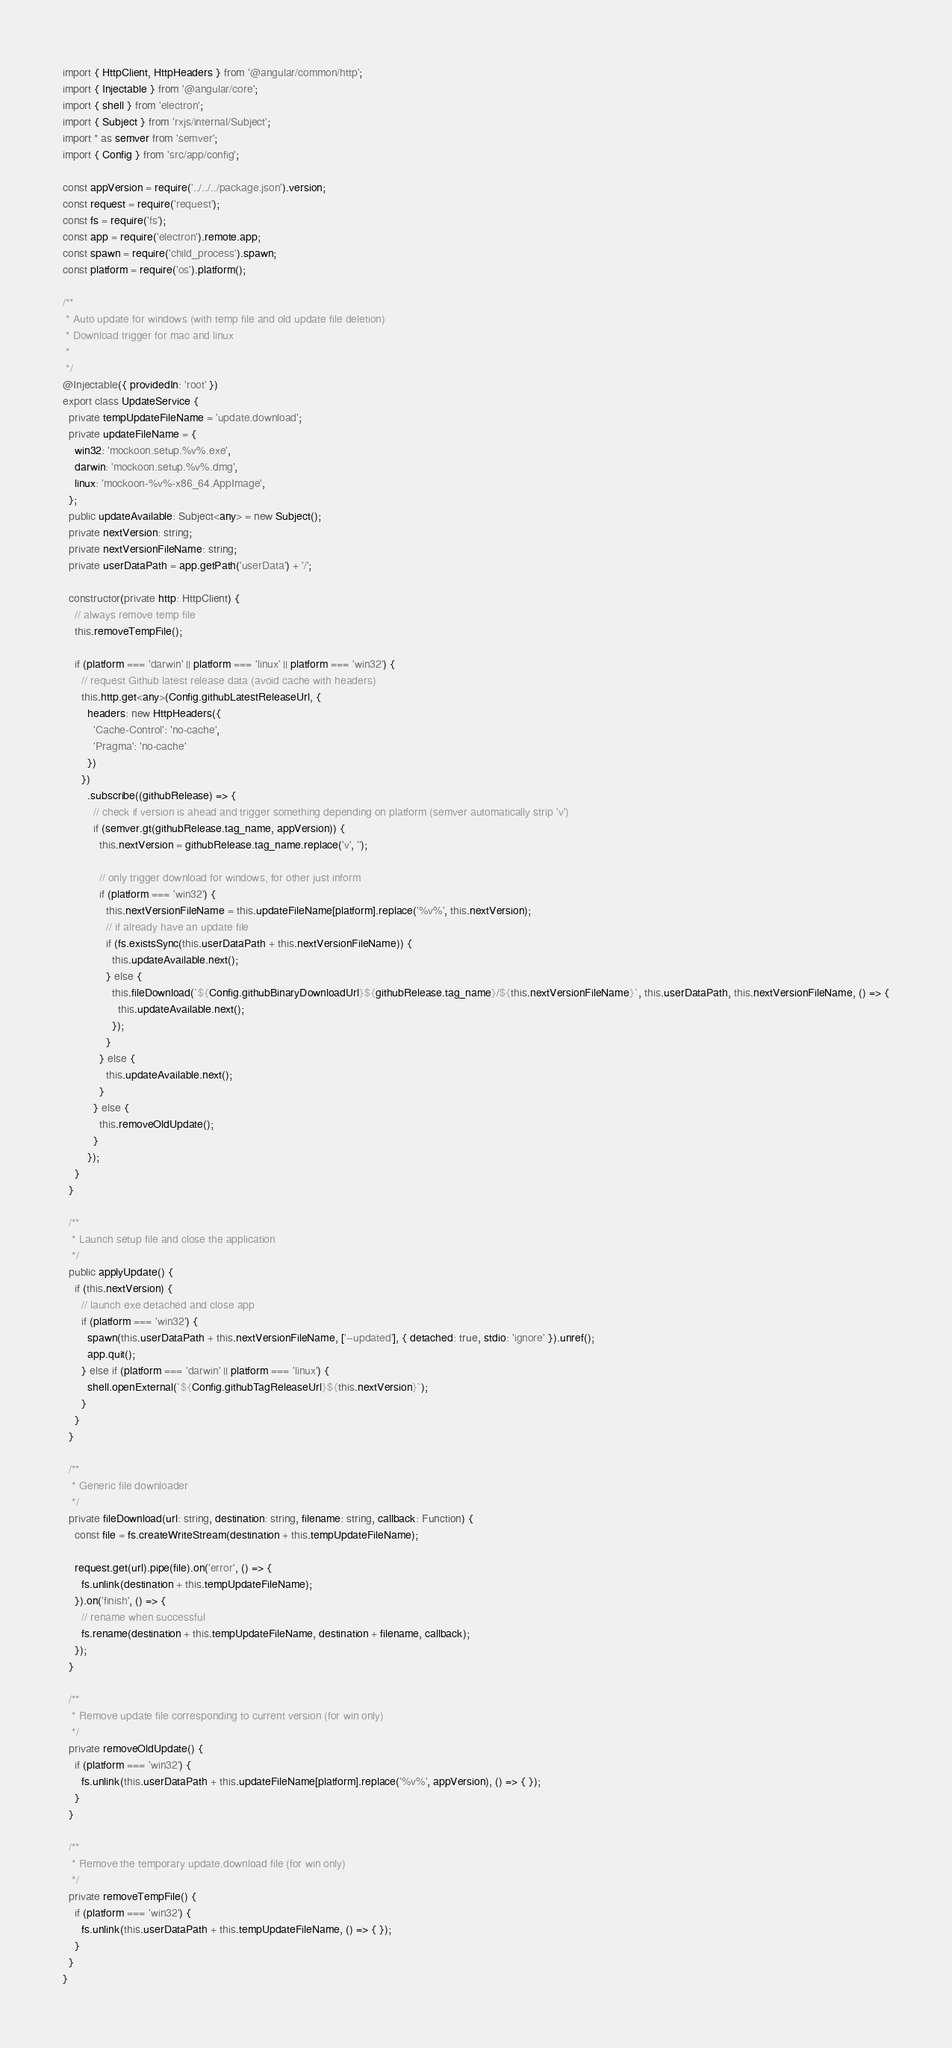Convert code to text. <code><loc_0><loc_0><loc_500><loc_500><_TypeScript_>import { HttpClient, HttpHeaders } from '@angular/common/http';
import { Injectable } from '@angular/core';
import { shell } from 'electron';
import { Subject } from 'rxjs/internal/Subject';
import * as semver from 'semver';
import { Config } from 'src/app/config';

const appVersion = require('../../../package.json').version;
const request = require('request');
const fs = require('fs');
const app = require('electron').remote.app;
const spawn = require('child_process').spawn;
const platform = require('os').platform();

/**
 * Auto update for windows (with temp file and old update file deletion)
 * Download trigger for mac and linux
 *
 */
@Injectable({ providedIn: 'root' })
export class UpdateService {
  private tempUpdateFileName = 'update.download';
  private updateFileName = {
    win32: 'mockoon.setup.%v%.exe',
    darwin: 'mockoon.setup.%v%.dmg',
    linux: 'mockoon-%v%-x86_64.AppImage',
  };
  public updateAvailable: Subject<any> = new Subject();
  private nextVersion: string;
  private nextVersionFileName: string;
  private userDataPath = app.getPath('userData') + '/';

  constructor(private http: HttpClient) {
    // always remove temp file
    this.removeTempFile();

    if (platform === 'darwin' || platform === 'linux' || platform === 'win32') {
      // request Github latest release data (avoid cache with headers)
      this.http.get<any>(Config.githubLatestReleaseUrl, {
        headers: new HttpHeaders({
          'Cache-Control': 'no-cache',
          'Pragma': 'no-cache'
        })
      })
        .subscribe((githubRelease) => {
          // check if version is ahead and trigger something depending on platform (semver automatically strip 'v')
          if (semver.gt(githubRelease.tag_name, appVersion)) {
            this.nextVersion = githubRelease.tag_name.replace('v', '');

            // only trigger download for windows, for other just inform
            if (platform === 'win32') {
              this.nextVersionFileName = this.updateFileName[platform].replace('%v%', this.nextVersion);
              // if already have an update file
              if (fs.existsSync(this.userDataPath + this.nextVersionFileName)) {
                this.updateAvailable.next();
              } else {
                this.fileDownload(`${Config.githubBinaryDownloadUrl}${githubRelease.tag_name}/${this.nextVersionFileName}`, this.userDataPath, this.nextVersionFileName, () => {
                  this.updateAvailable.next();
                });
              }
            } else {
              this.updateAvailable.next();
            }
          } else {
            this.removeOldUpdate();
          }
        });
    }
  }

  /**
   * Launch setup file and close the application
   */
  public applyUpdate() {
    if (this.nextVersion) {
      // launch exe detached and close app
      if (platform === 'win32') {
        spawn(this.userDataPath + this.nextVersionFileName, ['--updated'], { detached: true, stdio: 'ignore' }).unref();
        app.quit();
      } else if (platform === 'darwin' || platform === 'linux') {
        shell.openExternal(`${Config.githubTagReleaseUrl}${this.nextVersion}`);
      }
    }
  }

  /**
   * Generic file downloader
   */
  private fileDownload(url: string, destination: string, filename: string, callback: Function) {
    const file = fs.createWriteStream(destination + this.tempUpdateFileName);

    request.get(url).pipe(file).on('error', () => {
      fs.unlink(destination + this.tempUpdateFileName);
    }).on('finish', () => {
      // rename when successful
      fs.rename(destination + this.tempUpdateFileName, destination + filename, callback);
    });
  }

  /**
   * Remove update file corresponding to current version (for win only)
   */
  private removeOldUpdate() {
    if (platform === 'win32') {
      fs.unlink(this.userDataPath + this.updateFileName[platform].replace('%v%', appVersion), () => { });
    }
  }

  /**
   * Remove the temporary update.download file (for win only)
   */
  private removeTempFile() {
    if (platform === 'win32') {
      fs.unlink(this.userDataPath + this.tempUpdateFileName, () => { });
    }
  }
}
</code> 